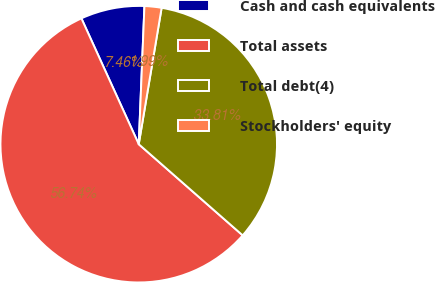Convert chart to OTSL. <chart><loc_0><loc_0><loc_500><loc_500><pie_chart><fcel>Cash and cash equivalents<fcel>Total assets<fcel>Total debt(4)<fcel>Stockholders' equity<nl><fcel>7.46%<fcel>56.73%<fcel>33.81%<fcel>1.99%<nl></chart> 